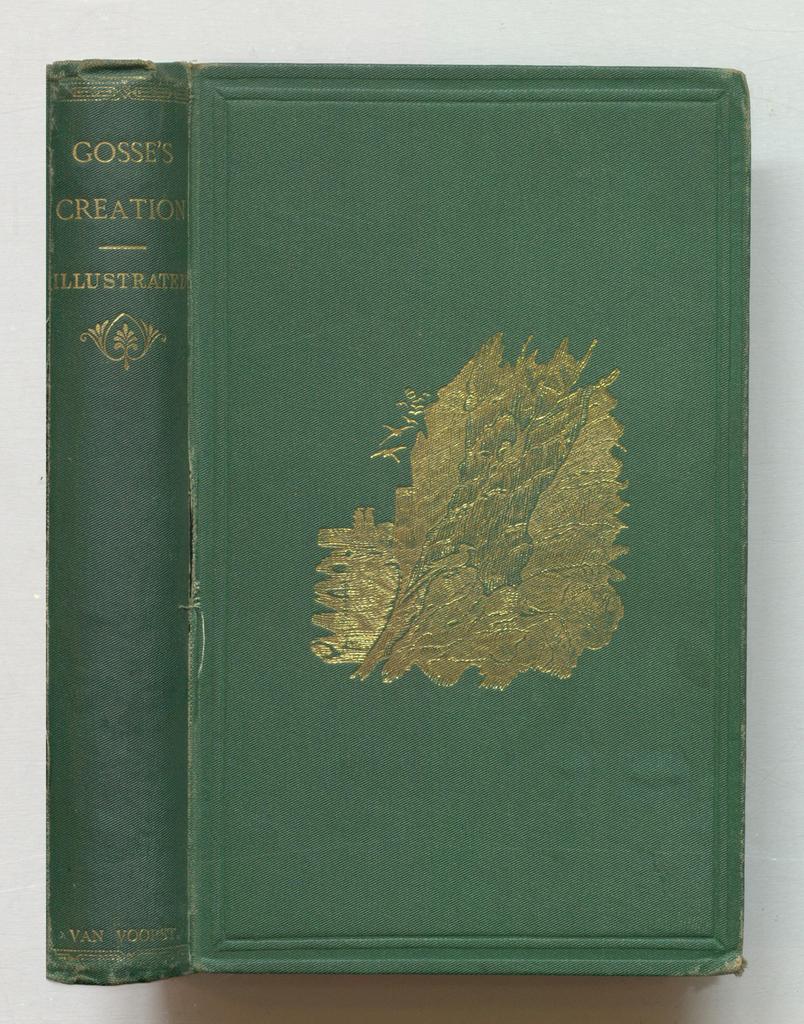Who wrote this book?
Your answer should be compact. Van voorst. 